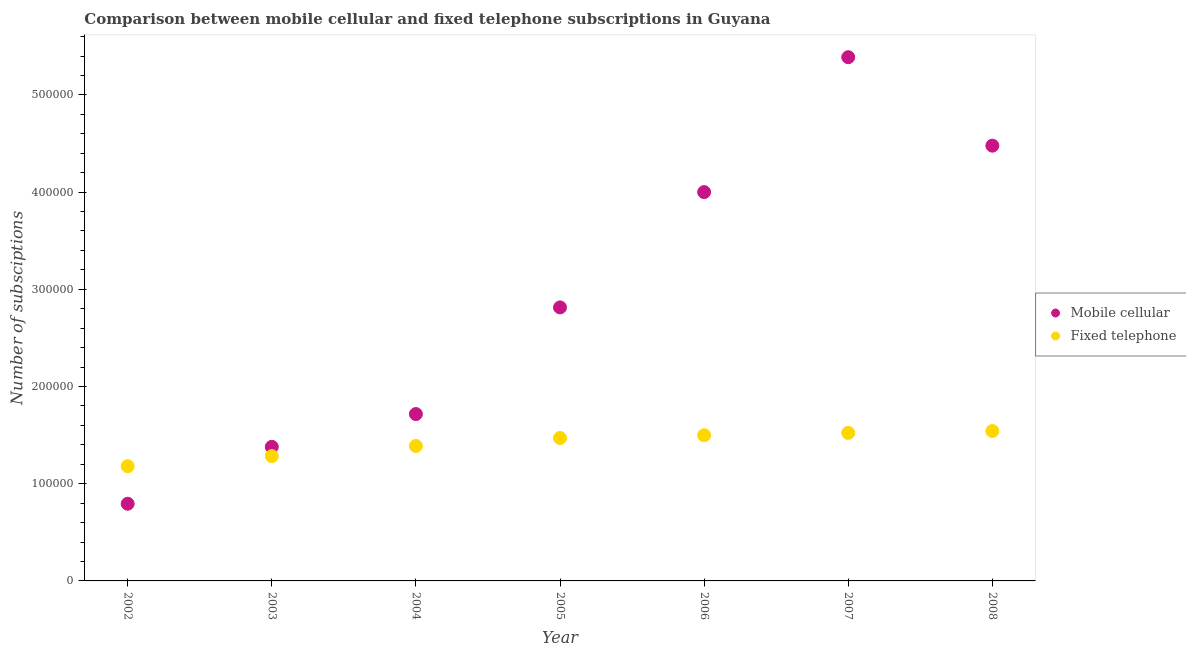Is the number of dotlines equal to the number of legend labels?
Give a very brief answer. Yes. What is the number of fixed telephone subscriptions in 2007?
Give a very brief answer. 1.52e+05. Across all years, what is the maximum number of fixed telephone subscriptions?
Offer a very short reply. 1.54e+05. Across all years, what is the minimum number of mobile cellular subscriptions?
Provide a short and direct response. 7.94e+04. In which year was the number of fixed telephone subscriptions maximum?
Give a very brief answer. 2008. What is the total number of mobile cellular subscriptions in the graph?
Make the answer very short. 2.06e+06. What is the difference between the number of mobile cellular subscriptions in 2002 and that in 2006?
Your answer should be compact. -3.21e+05. What is the difference between the number of fixed telephone subscriptions in 2003 and the number of mobile cellular subscriptions in 2002?
Keep it short and to the point. 4.90e+04. What is the average number of mobile cellular subscriptions per year?
Keep it short and to the point. 2.94e+05. In the year 2008, what is the difference between the number of fixed telephone subscriptions and number of mobile cellular subscriptions?
Your response must be concise. -2.94e+05. What is the ratio of the number of mobile cellular subscriptions in 2002 to that in 2005?
Make the answer very short. 0.28. What is the difference between the highest and the second highest number of mobile cellular subscriptions?
Your answer should be very brief. 9.10e+04. What is the difference between the highest and the lowest number of fixed telephone subscriptions?
Keep it short and to the point. 3.62e+04. Is the sum of the number of fixed telephone subscriptions in 2002 and 2005 greater than the maximum number of mobile cellular subscriptions across all years?
Keep it short and to the point. No. Does the number of mobile cellular subscriptions monotonically increase over the years?
Ensure brevity in your answer.  No. How many dotlines are there?
Offer a very short reply. 2. What is the difference between two consecutive major ticks on the Y-axis?
Make the answer very short. 1.00e+05. Are the values on the major ticks of Y-axis written in scientific E-notation?
Give a very brief answer. No. Where does the legend appear in the graph?
Ensure brevity in your answer.  Center right. What is the title of the graph?
Provide a succinct answer. Comparison between mobile cellular and fixed telephone subscriptions in Guyana. What is the label or title of the X-axis?
Provide a succinct answer. Year. What is the label or title of the Y-axis?
Offer a terse response. Number of subsciptions. What is the Number of subsciptions in Mobile cellular in 2002?
Your answer should be compact. 7.94e+04. What is the Number of subsciptions in Fixed telephone in 2002?
Provide a succinct answer. 1.18e+05. What is the Number of subsciptions in Mobile cellular in 2003?
Keep it short and to the point. 1.38e+05. What is the Number of subsciptions of Fixed telephone in 2003?
Provide a succinct answer. 1.28e+05. What is the Number of subsciptions in Mobile cellular in 2004?
Offer a very short reply. 1.72e+05. What is the Number of subsciptions of Fixed telephone in 2004?
Provide a succinct answer. 1.39e+05. What is the Number of subsciptions in Mobile cellular in 2005?
Ensure brevity in your answer.  2.81e+05. What is the Number of subsciptions of Fixed telephone in 2005?
Offer a terse response. 1.47e+05. What is the Number of subsciptions of Fixed telephone in 2006?
Keep it short and to the point. 1.50e+05. What is the Number of subsciptions in Mobile cellular in 2007?
Ensure brevity in your answer.  5.39e+05. What is the Number of subsciptions in Fixed telephone in 2007?
Provide a succinct answer. 1.52e+05. What is the Number of subsciptions of Mobile cellular in 2008?
Keep it short and to the point. 4.48e+05. What is the Number of subsciptions in Fixed telephone in 2008?
Offer a terse response. 1.54e+05. Across all years, what is the maximum Number of subsciptions of Mobile cellular?
Make the answer very short. 5.39e+05. Across all years, what is the maximum Number of subsciptions of Fixed telephone?
Provide a succinct answer. 1.54e+05. Across all years, what is the minimum Number of subsciptions of Mobile cellular?
Your answer should be compact. 7.94e+04. Across all years, what is the minimum Number of subsciptions of Fixed telephone?
Your answer should be very brief. 1.18e+05. What is the total Number of subsciptions in Mobile cellular in the graph?
Provide a succinct answer. 2.06e+06. What is the total Number of subsciptions in Fixed telephone in the graph?
Provide a short and direct response. 9.89e+05. What is the difference between the Number of subsciptions in Mobile cellular in 2002 and that in 2003?
Provide a short and direct response. -5.86e+04. What is the difference between the Number of subsciptions in Fixed telephone in 2002 and that in 2003?
Offer a terse response. -1.04e+04. What is the difference between the Number of subsciptions in Mobile cellular in 2002 and that in 2004?
Offer a terse response. -9.23e+04. What is the difference between the Number of subsciptions of Fixed telephone in 2002 and that in 2004?
Keep it short and to the point. -2.08e+04. What is the difference between the Number of subsciptions in Mobile cellular in 2002 and that in 2005?
Ensure brevity in your answer.  -2.02e+05. What is the difference between the Number of subsciptions in Fixed telephone in 2002 and that in 2005?
Provide a short and direct response. -2.90e+04. What is the difference between the Number of subsciptions in Mobile cellular in 2002 and that in 2006?
Offer a very short reply. -3.21e+05. What is the difference between the Number of subsciptions in Fixed telephone in 2002 and that in 2006?
Your answer should be compact. -3.19e+04. What is the difference between the Number of subsciptions in Mobile cellular in 2002 and that in 2007?
Offer a very short reply. -4.59e+05. What is the difference between the Number of subsciptions in Fixed telephone in 2002 and that in 2007?
Offer a terse response. -3.43e+04. What is the difference between the Number of subsciptions of Mobile cellular in 2002 and that in 2008?
Offer a terse response. -3.68e+05. What is the difference between the Number of subsciptions of Fixed telephone in 2002 and that in 2008?
Your response must be concise. -3.62e+04. What is the difference between the Number of subsciptions in Mobile cellular in 2003 and that in 2004?
Make the answer very short. -3.37e+04. What is the difference between the Number of subsciptions of Fixed telephone in 2003 and that in 2004?
Provide a succinct answer. -1.04e+04. What is the difference between the Number of subsciptions of Mobile cellular in 2003 and that in 2005?
Your response must be concise. -1.43e+05. What is the difference between the Number of subsciptions in Fixed telephone in 2003 and that in 2005?
Your answer should be compact. -1.86e+04. What is the difference between the Number of subsciptions in Mobile cellular in 2003 and that in 2006?
Provide a short and direct response. -2.62e+05. What is the difference between the Number of subsciptions in Fixed telephone in 2003 and that in 2006?
Offer a very short reply. -2.15e+04. What is the difference between the Number of subsciptions in Mobile cellular in 2003 and that in 2007?
Give a very brief answer. -4.01e+05. What is the difference between the Number of subsciptions in Fixed telephone in 2003 and that in 2007?
Your answer should be very brief. -2.39e+04. What is the difference between the Number of subsciptions in Mobile cellular in 2003 and that in 2008?
Ensure brevity in your answer.  -3.10e+05. What is the difference between the Number of subsciptions of Fixed telephone in 2003 and that in 2008?
Offer a very short reply. -2.58e+04. What is the difference between the Number of subsciptions in Mobile cellular in 2004 and that in 2005?
Offer a very short reply. -1.10e+05. What is the difference between the Number of subsciptions in Fixed telephone in 2004 and that in 2005?
Offer a very short reply. -8220. What is the difference between the Number of subsciptions of Mobile cellular in 2004 and that in 2006?
Provide a short and direct response. -2.28e+05. What is the difference between the Number of subsciptions of Fixed telephone in 2004 and that in 2006?
Provide a short and direct response. -1.10e+04. What is the difference between the Number of subsciptions of Mobile cellular in 2004 and that in 2007?
Your answer should be compact. -3.67e+05. What is the difference between the Number of subsciptions of Fixed telephone in 2004 and that in 2007?
Provide a succinct answer. -1.35e+04. What is the difference between the Number of subsciptions in Mobile cellular in 2004 and that in 2008?
Ensure brevity in your answer.  -2.76e+05. What is the difference between the Number of subsciptions of Fixed telephone in 2004 and that in 2008?
Your answer should be compact. -1.54e+04. What is the difference between the Number of subsciptions in Mobile cellular in 2005 and that in 2006?
Provide a succinct answer. -1.19e+05. What is the difference between the Number of subsciptions of Fixed telephone in 2005 and that in 2006?
Keep it short and to the point. -2815. What is the difference between the Number of subsciptions of Mobile cellular in 2005 and that in 2007?
Your answer should be very brief. -2.57e+05. What is the difference between the Number of subsciptions of Fixed telephone in 2005 and that in 2007?
Your answer should be compact. -5257. What is the difference between the Number of subsciptions in Mobile cellular in 2005 and that in 2008?
Provide a succinct answer. -1.66e+05. What is the difference between the Number of subsciptions in Fixed telephone in 2005 and that in 2008?
Your answer should be very brief. -7165. What is the difference between the Number of subsciptions of Mobile cellular in 2006 and that in 2007?
Your answer should be very brief. -1.39e+05. What is the difference between the Number of subsciptions of Fixed telephone in 2006 and that in 2007?
Your response must be concise. -2442. What is the difference between the Number of subsciptions of Mobile cellular in 2006 and that in 2008?
Make the answer very short. -4.78e+04. What is the difference between the Number of subsciptions in Fixed telephone in 2006 and that in 2008?
Your answer should be compact. -4350. What is the difference between the Number of subsciptions in Mobile cellular in 2007 and that in 2008?
Give a very brief answer. 9.10e+04. What is the difference between the Number of subsciptions in Fixed telephone in 2007 and that in 2008?
Offer a very short reply. -1908. What is the difference between the Number of subsciptions in Mobile cellular in 2002 and the Number of subsciptions in Fixed telephone in 2003?
Offer a terse response. -4.90e+04. What is the difference between the Number of subsciptions in Mobile cellular in 2002 and the Number of subsciptions in Fixed telephone in 2004?
Provide a short and direct response. -5.94e+04. What is the difference between the Number of subsciptions in Mobile cellular in 2002 and the Number of subsciptions in Fixed telephone in 2005?
Your answer should be very brief. -6.76e+04. What is the difference between the Number of subsciptions in Mobile cellular in 2002 and the Number of subsciptions in Fixed telephone in 2006?
Provide a succinct answer. -7.05e+04. What is the difference between the Number of subsciptions of Mobile cellular in 2002 and the Number of subsciptions of Fixed telephone in 2007?
Your answer should be compact. -7.29e+04. What is the difference between the Number of subsciptions in Mobile cellular in 2002 and the Number of subsciptions in Fixed telephone in 2008?
Ensure brevity in your answer.  -7.48e+04. What is the difference between the Number of subsciptions of Mobile cellular in 2003 and the Number of subsciptions of Fixed telephone in 2004?
Your response must be concise. -867. What is the difference between the Number of subsciptions in Mobile cellular in 2003 and the Number of subsciptions in Fixed telephone in 2005?
Offer a terse response. -9087. What is the difference between the Number of subsciptions of Mobile cellular in 2003 and the Number of subsciptions of Fixed telephone in 2006?
Make the answer very short. -1.19e+04. What is the difference between the Number of subsciptions of Mobile cellular in 2003 and the Number of subsciptions of Fixed telephone in 2007?
Your answer should be very brief. -1.43e+04. What is the difference between the Number of subsciptions in Mobile cellular in 2003 and the Number of subsciptions in Fixed telephone in 2008?
Ensure brevity in your answer.  -1.63e+04. What is the difference between the Number of subsciptions of Mobile cellular in 2004 and the Number of subsciptions of Fixed telephone in 2005?
Your answer should be compact. 2.46e+04. What is the difference between the Number of subsciptions in Mobile cellular in 2004 and the Number of subsciptions in Fixed telephone in 2006?
Your answer should be very brief. 2.18e+04. What is the difference between the Number of subsciptions of Mobile cellular in 2004 and the Number of subsciptions of Fixed telephone in 2007?
Offer a terse response. 1.94e+04. What is the difference between the Number of subsciptions of Mobile cellular in 2004 and the Number of subsciptions of Fixed telephone in 2008?
Offer a terse response. 1.74e+04. What is the difference between the Number of subsciptions in Mobile cellular in 2005 and the Number of subsciptions in Fixed telephone in 2006?
Offer a very short reply. 1.32e+05. What is the difference between the Number of subsciptions in Mobile cellular in 2005 and the Number of subsciptions in Fixed telephone in 2007?
Provide a succinct answer. 1.29e+05. What is the difference between the Number of subsciptions of Mobile cellular in 2005 and the Number of subsciptions of Fixed telephone in 2008?
Offer a very short reply. 1.27e+05. What is the difference between the Number of subsciptions of Mobile cellular in 2006 and the Number of subsciptions of Fixed telephone in 2007?
Ensure brevity in your answer.  2.48e+05. What is the difference between the Number of subsciptions in Mobile cellular in 2006 and the Number of subsciptions in Fixed telephone in 2008?
Give a very brief answer. 2.46e+05. What is the difference between the Number of subsciptions in Mobile cellular in 2007 and the Number of subsciptions in Fixed telephone in 2008?
Offer a very short reply. 3.85e+05. What is the average Number of subsciptions in Mobile cellular per year?
Provide a short and direct response. 2.94e+05. What is the average Number of subsciptions of Fixed telephone per year?
Your answer should be very brief. 1.41e+05. In the year 2002, what is the difference between the Number of subsciptions in Mobile cellular and Number of subsciptions in Fixed telephone?
Your answer should be compact. -3.86e+04. In the year 2003, what is the difference between the Number of subsciptions in Mobile cellular and Number of subsciptions in Fixed telephone?
Make the answer very short. 9561. In the year 2004, what is the difference between the Number of subsciptions of Mobile cellular and Number of subsciptions of Fixed telephone?
Your answer should be very brief. 3.28e+04. In the year 2005, what is the difference between the Number of subsciptions in Mobile cellular and Number of subsciptions in Fixed telephone?
Your answer should be very brief. 1.34e+05. In the year 2006, what is the difference between the Number of subsciptions of Mobile cellular and Number of subsciptions of Fixed telephone?
Your answer should be very brief. 2.50e+05. In the year 2007, what is the difference between the Number of subsciptions of Mobile cellular and Number of subsciptions of Fixed telephone?
Keep it short and to the point. 3.86e+05. In the year 2008, what is the difference between the Number of subsciptions in Mobile cellular and Number of subsciptions in Fixed telephone?
Provide a short and direct response. 2.94e+05. What is the ratio of the Number of subsciptions of Mobile cellular in 2002 to that in 2003?
Offer a terse response. 0.58. What is the ratio of the Number of subsciptions of Fixed telephone in 2002 to that in 2003?
Give a very brief answer. 0.92. What is the ratio of the Number of subsciptions in Mobile cellular in 2002 to that in 2004?
Provide a succinct answer. 0.46. What is the ratio of the Number of subsciptions in Fixed telephone in 2002 to that in 2004?
Keep it short and to the point. 0.85. What is the ratio of the Number of subsciptions in Mobile cellular in 2002 to that in 2005?
Your answer should be very brief. 0.28. What is the ratio of the Number of subsciptions in Fixed telephone in 2002 to that in 2005?
Keep it short and to the point. 0.8. What is the ratio of the Number of subsciptions in Mobile cellular in 2002 to that in 2006?
Offer a terse response. 0.2. What is the ratio of the Number of subsciptions of Fixed telephone in 2002 to that in 2006?
Give a very brief answer. 0.79. What is the ratio of the Number of subsciptions in Mobile cellular in 2002 to that in 2007?
Ensure brevity in your answer.  0.15. What is the ratio of the Number of subsciptions in Fixed telephone in 2002 to that in 2007?
Offer a terse response. 0.77. What is the ratio of the Number of subsciptions of Mobile cellular in 2002 to that in 2008?
Offer a very short reply. 0.18. What is the ratio of the Number of subsciptions in Fixed telephone in 2002 to that in 2008?
Your answer should be compact. 0.77. What is the ratio of the Number of subsciptions of Mobile cellular in 2003 to that in 2004?
Provide a succinct answer. 0.8. What is the ratio of the Number of subsciptions in Fixed telephone in 2003 to that in 2004?
Your answer should be compact. 0.92. What is the ratio of the Number of subsciptions of Mobile cellular in 2003 to that in 2005?
Provide a succinct answer. 0.49. What is the ratio of the Number of subsciptions of Fixed telephone in 2003 to that in 2005?
Give a very brief answer. 0.87. What is the ratio of the Number of subsciptions in Mobile cellular in 2003 to that in 2006?
Keep it short and to the point. 0.34. What is the ratio of the Number of subsciptions in Fixed telephone in 2003 to that in 2006?
Offer a terse response. 0.86. What is the ratio of the Number of subsciptions of Mobile cellular in 2003 to that in 2007?
Your answer should be compact. 0.26. What is the ratio of the Number of subsciptions of Fixed telephone in 2003 to that in 2007?
Provide a short and direct response. 0.84. What is the ratio of the Number of subsciptions of Mobile cellular in 2003 to that in 2008?
Offer a terse response. 0.31. What is the ratio of the Number of subsciptions of Fixed telephone in 2003 to that in 2008?
Make the answer very short. 0.83. What is the ratio of the Number of subsciptions in Mobile cellular in 2004 to that in 2005?
Keep it short and to the point. 0.61. What is the ratio of the Number of subsciptions in Fixed telephone in 2004 to that in 2005?
Provide a short and direct response. 0.94. What is the ratio of the Number of subsciptions in Mobile cellular in 2004 to that in 2006?
Ensure brevity in your answer.  0.43. What is the ratio of the Number of subsciptions in Fixed telephone in 2004 to that in 2006?
Ensure brevity in your answer.  0.93. What is the ratio of the Number of subsciptions in Mobile cellular in 2004 to that in 2007?
Provide a short and direct response. 0.32. What is the ratio of the Number of subsciptions in Fixed telephone in 2004 to that in 2007?
Offer a very short reply. 0.91. What is the ratio of the Number of subsciptions of Mobile cellular in 2004 to that in 2008?
Your answer should be compact. 0.38. What is the ratio of the Number of subsciptions of Fixed telephone in 2004 to that in 2008?
Give a very brief answer. 0.9. What is the ratio of the Number of subsciptions of Mobile cellular in 2005 to that in 2006?
Offer a terse response. 0.7. What is the ratio of the Number of subsciptions of Fixed telephone in 2005 to that in 2006?
Offer a very short reply. 0.98. What is the ratio of the Number of subsciptions of Mobile cellular in 2005 to that in 2007?
Provide a short and direct response. 0.52. What is the ratio of the Number of subsciptions of Fixed telephone in 2005 to that in 2007?
Your response must be concise. 0.97. What is the ratio of the Number of subsciptions of Mobile cellular in 2005 to that in 2008?
Your answer should be very brief. 0.63. What is the ratio of the Number of subsciptions of Fixed telephone in 2005 to that in 2008?
Make the answer very short. 0.95. What is the ratio of the Number of subsciptions of Mobile cellular in 2006 to that in 2007?
Your answer should be compact. 0.74. What is the ratio of the Number of subsciptions in Mobile cellular in 2006 to that in 2008?
Keep it short and to the point. 0.89. What is the ratio of the Number of subsciptions of Fixed telephone in 2006 to that in 2008?
Your answer should be compact. 0.97. What is the ratio of the Number of subsciptions of Mobile cellular in 2007 to that in 2008?
Offer a very short reply. 1.2. What is the ratio of the Number of subsciptions of Fixed telephone in 2007 to that in 2008?
Your answer should be compact. 0.99. What is the difference between the highest and the second highest Number of subsciptions of Mobile cellular?
Offer a terse response. 9.10e+04. What is the difference between the highest and the second highest Number of subsciptions of Fixed telephone?
Your answer should be very brief. 1908. What is the difference between the highest and the lowest Number of subsciptions in Mobile cellular?
Offer a terse response. 4.59e+05. What is the difference between the highest and the lowest Number of subsciptions in Fixed telephone?
Offer a very short reply. 3.62e+04. 